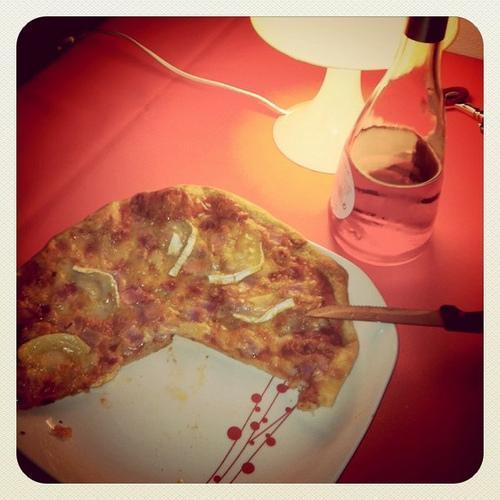How many knives are on the plate?
Give a very brief answer. 1. 